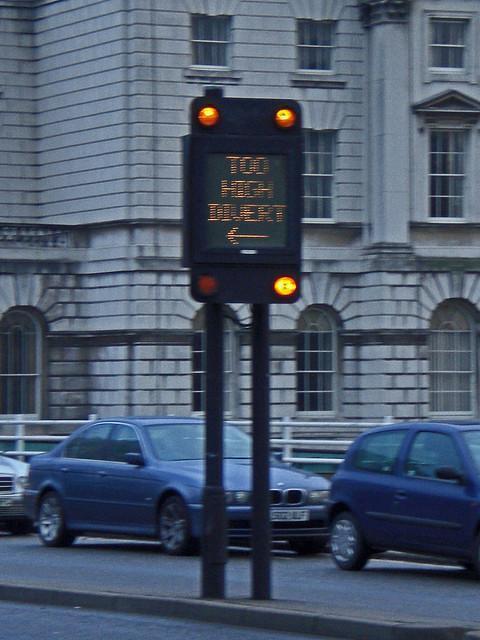How many cars are in the photo?
Give a very brief answer. 2. 